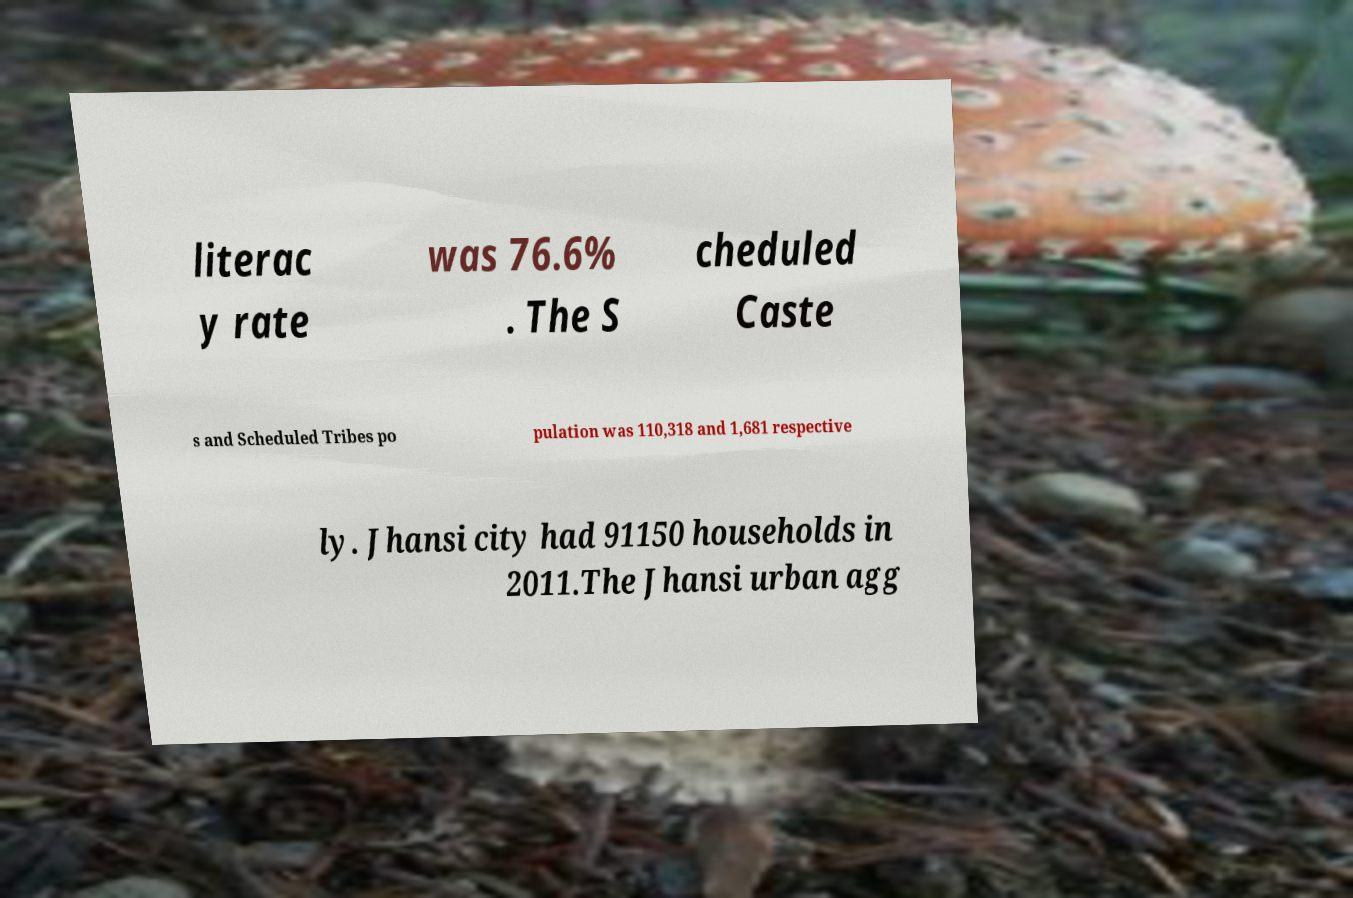Can you read and provide the text displayed in the image?This photo seems to have some interesting text. Can you extract and type it out for me? literac y rate was 76.6% . The S cheduled Caste s and Scheduled Tribes po pulation was 110,318 and 1,681 respective ly. Jhansi city had 91150 households in 2011.The Jhansi urban agg 